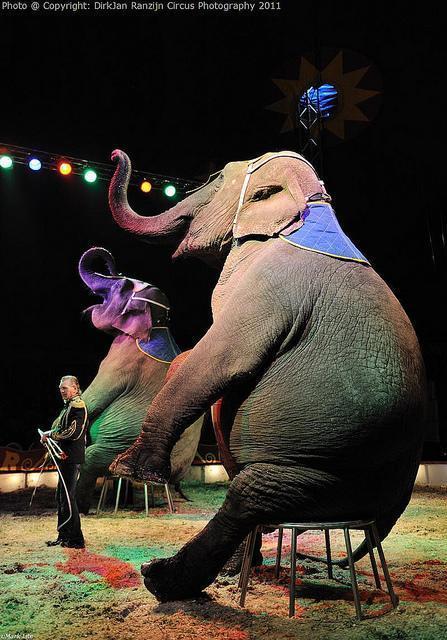How many elephants are in the scene?
Give a very brief answer. 2. How many elephants are in the photo?
Give a very brief answer. 2. 